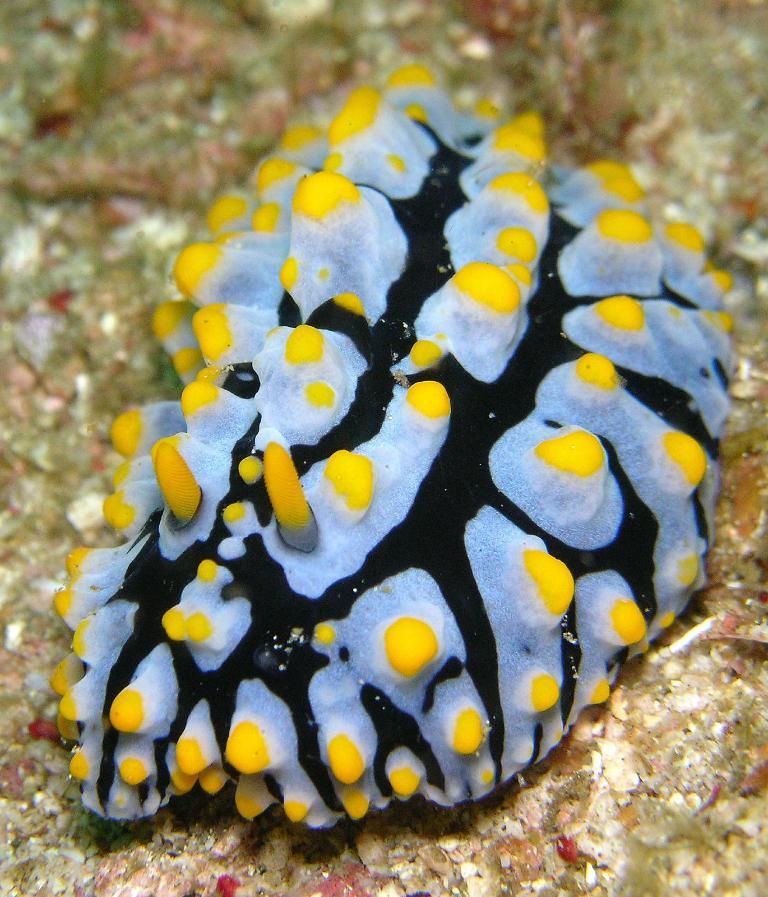What type of animal is in the image? There is a sea slug in the image. Where is the sea slug located in the image? The sea slug is present on the ground. What type of tray is being used to carry the sea slug in the image? There is no tray present in the image, as the sea slug is on the ground. How does the sea slug communicate with other sea slugs in the image? The image does not provide information about how the sea slug communicates with other sea slugs. 